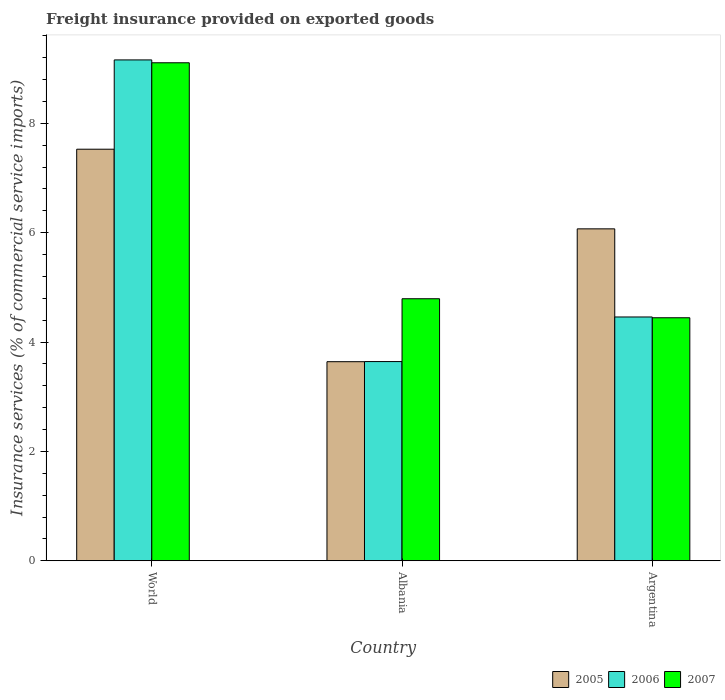How many groups of bars are there?
Ensure brevity in your answer.  3. Are the number of bars on each tick of the X-axis equal?
Your answer should be compact. Yes. How many bars are there on the 3rd tick from the left?
Your response must be concise. 3. What is the label of the 3rd group of bars from the left?
Provide a short and direct response. Argentina. What is the freight insurance provided on exported goods in 2006 in Argentina?
Your answer should be compact. 4.46. Across all countries, what is the maximum freight insurance provided on exported goods in 2007?
Offer a terse response. 9.11. Across all countries, what is the minimum freight insurance provided on exported goods in 2006?
Keep it short and to the point. 3.64. In which country was the freight insurance provided on exported goods in 2007 maximum?
Offer a terse response. World. In which country was the freight insurance provided on exported goods in 2005 minimum?
Your answer should be compact. Albania. What is the total freight insurance provided on exported goods in 2006 in the graph?
Your answer should be very brief. 17.26. What is the difference between the freight insurance provided on exported goods in 2006 in Argentina and that in World?
Ensure brevity in your answer.  -4.7. What is the difference between the freight insurance provided on exported goods in 2005 in Albania and the freight insurance provided on exported goods in 2007 in World?
Ensure brevity in your answer.  -5.47. What is the average freight insurance provided on exported goods in 2007 per country?
Make the answer very short. 6.11. What is the difference between the freight insurance provided on exported goods of/in 2005 and freight insurance provided on exported goods of/in 2007 in World?
Provide a short and direct response. -1.58. In how many countries, is the freight insurance provided on exported goods in 2007 greater than 4.8 %?
Give a very brief answer. 1. What is the ratio of the freight insurance provided on exported goods in 2005 in Albania to that in World?
Your answer should be very brief. 0.48. Is the freight insurance provided on exported goods in 2006 in Albania less than that in Argentina?
Your response must be concise. Yes. Is the difference between the freight insurance provided on exported goods in 2005 in Albania and World greater than the difference between the freight insurance provided on exported goods in 2007 in Albania and World?
Keep it short and to the point. Yes. What is the difference between the highest and the second highest freight insurance provided on exported goods in 2006?
Offer a terse response. 5.52. What is the difference between the highest and the lowest freight insurance provided on exported goods in 2005?
Ensure brevity in your answer.  3.89. In how many countries, is the freight insurance provided on exported goods in 2006 greater than the average freight insurance provided on exported goods in 2006 taken over all countries?
Your answer should be very brief. 1. What does the 2nd bar from the right in World represents?
Ensure brevity in your answer.  2006. How many bars are there?
Make the answer very short. 9. Are all the bars in the graph horizontal?
Provide a succinct answer. No. Are the values on the major ticks of Y-axis written in scientific E-notation?
Ensure brevity in your answer.  No. Does the graph contain grids?
Offer a very short reply. No. How are the legend labels stacked?
Ensure brevity in your answer.  Horizontal. What is the title of the graph?
Give a very brief answer. Freight insurance provided on exported goods. Does "1994" appear as one of the legend labels in the graph?
Provide a succinct answer. No. What is the label or title of the Y-axis?
Offer a very short reply. Insurance services (% of commercial service imports). What is the Insurance services (% of commercial service imports) in 2005 in World?
Offer a terse response. 7.53. What is the Insurance services (% of commercial service imports) in 2006 in World?
Keep it short and to the point. 9.16. What is the Insurance services (% of commercial service imports) of 2007 in World?
Your answer should be compact. 9.11. What is the Insurance services (% of commercial service imports) of 2005 in Albania?
Provide a succinct answer. 3.64. What is the Insurance services (% of commercial service imports) of 2006 in Albania?
Provide a succinct answer. 3.64. What is the Insurance services (% of commercial service imports) in 2007 in Albania?
Keep it short and to the point. 4.79. What is the Insurance services (% of commercial service imports) of 2005 in Argentina?
Make the answer very short. 6.07. What is the Insurance services (% of commercial service imports) in 2006 in Argentina?
Provide a short and direct response. 4.46. What is the Insurance services (% of commercial service imports) in 2007 in Argentina?
Your response must be concise. 4.44. Across all countries, what is the maximum Insurance services (% of commercial service imports) of 2005?
Make the answer very short. 7.53. Across all countries, what is the maximum Insurance services (% of commercial service imports) in 2006?
Ensure brevity in your answer.  9.16. Across all countries, what is the maximum Insurance services (% of commercial service imports) of 2007?
Ensure brevity in your answer.  9.11. Across all countries, what is the minimum Insurance services (% of commercial service imports) of 2005?
Ensure brevity in your answer.  3.64. Across all countries, what is the minimum Insurance services (% of commercial service imports) of 2006?
Provide a short and direct response. 3.64. Across all countries, what is the minimum Insurance services (% of commercial service imports) in 2007?
Offer a very short reply. 4.44. What is the total Insurance services (% of commercial service imports) in 2005 in the graph?
Offer a terse response. 17.23. What is the total Insurance services (% of commercial service imports) of 2006 in the graph?
Keep it short and to the point. 17.26. What is the total Insurance services (% of commercial service imports) in 2007 in the graph?
Offer a very short reply. 18.34. What is the difference between the Insurance services (% of commercial service imports) of 2005 in World and that in Albania?
Ensure brevity in your answer.  3.89. What is the difference between the Insurance services (% of commercial service imports) of 2006 in World and that in Albania?
Offer a terse response. 5.52. What is the difference between the Insurance services (% of commercial service imports) of 2007 in World and that in Albania?
Your answer should be compact. 4.31. What is the difference between the Insurance services (% of commercial service imports) of 2005 in World and that in Argentina?
Your answer should be compact. 1.46. What is the difference between the Insurance services (% of commercial service imports) in 2006 in World and that in Argentina?
Provide a succinct answer. 4.7. What is the difference between the Insurance services (% of commercial service imports) of 2007 in World and that in Argentina?
Your answer should be very brief. 4.66. What is the difference between the Insurance services (% of commercial service imports) of 2005 in Albania and that in Argentina?
Your response must be concise. -2.43. What is the difference between the Insurance services (% of commercial service imports) in 2006 in Albania and that in Argentina?
Offer a terse response. -0.82. What is the difference between the Insurance services (% of commercial service imports) in 2007 in Albania and that in Argentina?
Offer a terse response. 0.35. What is the difference between the Insurance services (% of commercial service imports) in 2005 in World and the Insurance services (% of commercial service imports) in 2006 in Albania?
Offer a very short reply. 3.88. What is the difference between the Insurance services (% of commercial service imports) in 2005 in World and the Insurance services (% of commercial service imports) in 2007 in Albania?
Keep it short and to the point. 2.73. What is the difference between the Insurance services (% of commercial service imports) in 2006 in World and the Insurance services (% of commercial service imports) in 2007 in Albania?
Offer a terse response. 4.37. What is the difference between the Insurance services (% of commercial service imports) of 2005 in World and the Insurance services (% of commercial service imports) of 2006 in Argentina?
Your answer should be compact. 3.07. What is the difference between the Insurance services (% of commercial service imports) in 2005 in World and the Insurance services (% of commercial service imports) in 2007 in Argentina?
Give a very brief answer. 3.08. What is the difference between the Insurance services (% of commercial service imports) in 2006 in World and the Insurance services (% of commercial service imports) in 2007 in Argentina?
Offer a terse response. 4.71. What is the difference between the Insurance services (% of commercial service imports) of 2005 in Albania and the Insurance services (% of commercial service imports) of 2006 in Argentina?
Provide a short and direct response. -0.82. What is the difference between the Insurance services (% of commercial service imports) of 2005 in Albania and the Insurance services (% of commercial service imports) of 2007 in Argentina?
Your answer should be compact. -0.8. What is the difference between the Insurance services (% of commercial service imports) in 2006 in Albania and the Insurance services (% of commercial service imports) in 2007 in Argentina?
Make the answer very short. -0.8. What is the average Insurance services (% of commercial service imports) in 2005 per country?
Your answer should be very brief. 5.75. What is the average Insurance services (% of commercial service imports) in 2006 per country?
Offer a very short reply. 5.75. What is the average Insurance services (% of commercial service imports) of 2007 per country?
Your answer should be very brief. 6.11. What is the difference between the Insurance services (% of commercial service imports) in 2005 and Insurance services (% of commercial service imports) in 2006 in World?
Provide a succinct answer. -1.63. What is the difference between the Insurance services (% of commercial service imports) of 2005 and Insurance services (% of commercial service imports) of 2007 in World?
Your answer should be compact. -1.58. What is the difference between the Insurance services (% of commercial service imports) of 2006 and Insurance services (% of commercial service imports) of 2007 in World?
Your answer should be very brief. 0.05. What is the difference between the Insurance services (% of commercial service imports) in 2005 and Insurance services (% of commercial service imports) in 2006 in Albania?
Provide a short and direct response. -0. What is the difference between the Insurance services (% of commercial service imports) of 2005 and Insurance services (% of commercial service imports) of 2007 in Albania?
Provide a short and direct response. -1.15. What is the difference between the Insurance services (% of commercial service imports) in 2006 and Insurance services (% of commercial service imports) in 2007 in Albania?
Provide a short and direct response. -1.15. What is the difference between the Insurance services (% of commercial service imports) in 2005 and Insurance services (% of commercial service imports) in 2006 in Argentina?
Keep it short and to the point. 1.61. What is the difference between the Insurance services (% of commercial service imports) of 2005 and Insurance services (% of commercial service imports) of 2007 in Argentina?
Your response must be concise. 1.63. What is the difference between the Insurance services (% of commercial service imports) of 2006 and Insurance services (% of commercial service imports) of 2007 in Argentina?
Ensure brevity in your answer.  0.01. What is the ratio of the Insurance services (% of commercial service imports) in 2005 in World to that in Albania?
Your response must be concise. 2.07. What is the ratio of the Insurance services (% of commercial service imports) of 2006 in World to that in Albania?
Keep it short and to the point. 2.51. What is the ratio of the Insurance services (% of commercial service imports) in 2007 in World to that in Albania?
Make the answer very short. 1.9. What is the ratio of the Insurance services (% of commercial service imports) of 2005 in World to that in Argentina?
Ensure brevity in your answer.  1.24. What is the ratio of the Insurance services (% of commercial service imports) of 2006 in World to that in Argentina?
Your response must be concise. 2.05. What is the ratio of the Insurance services (% of commercial service imports) of 2007 in World to that in Argentina?
Make the answer very short. 2.05. What is the ratio of the Insurance services (% of commercial service imports) in 2005 in Albania to that in Argentina?
Give a very brief answer. 0.6. What is the ratio of the Insurance services (% of commercial service imports) in 2006 in Albania to that in Argentina?
Provide a succinct answer. 0.82. What is the ratio of the Insurance services (% of commercial service imports) in 2007 in Albania to that in Argentina?
Offer a very short reply. 1.08. What is the difference between the highest and the second highest Insurance services (% of commercial service imports) of 2005?
Your response must be concise. 1.46. What is the difference between the highest and the second highest Insurance services (% of commercial service imports) in 2006?
Make the answer very short. 4.7. What is the difference between the highest and the second highest Insurance services (% of commercial service imports) in 2007?
Give a very brief answer. 4.31. What is the difference between the highest and the lowest Insurance services (% of commercial service imports) in 2005?
Provide a short and direct response. 3.89. What is the difference between the highest and the lowest Insurance services (% of commercial service imports) in 2006?
Your response must be concise. 5.52. What is the difference between the highest and the lowest Insurance services (% of commercial service imports) in 2007?
Make the answer very short. 4.66. 